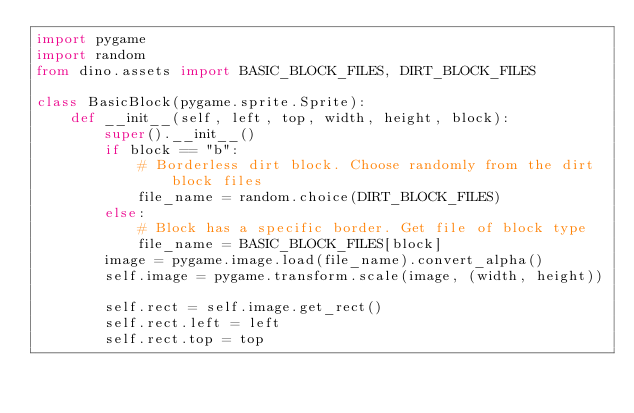Convert code to text. <code><loc_0><loc_0><loc_500><loc_500><_Python_>import pygame
import random
from dino.assets import BASIC_BLOCK_FILES, DIRT_BLOCK_FILES

class BasicBlock(pygame.sprite.Sprite):
    def __init__(self, left, top, width, height, block):
        super().__init__()
        if block == "b":
            # Borderless dirt block. Choose randomly from the dirt block files
            file_name = random.choice(DIRT_BLOCK_FILES)
        else:
            # Block has a specific border. Get file of block type
            file_name = BASIC_BLOCK_FILES[block]
        image = pygame.image.load(file_name).convert_alpha()
        self.image = pygame.transform.scale(image, (width, height))

        self.rect = self.image.get_rect()
        self.rect.left = left
        self.rect.top = top
</code> 